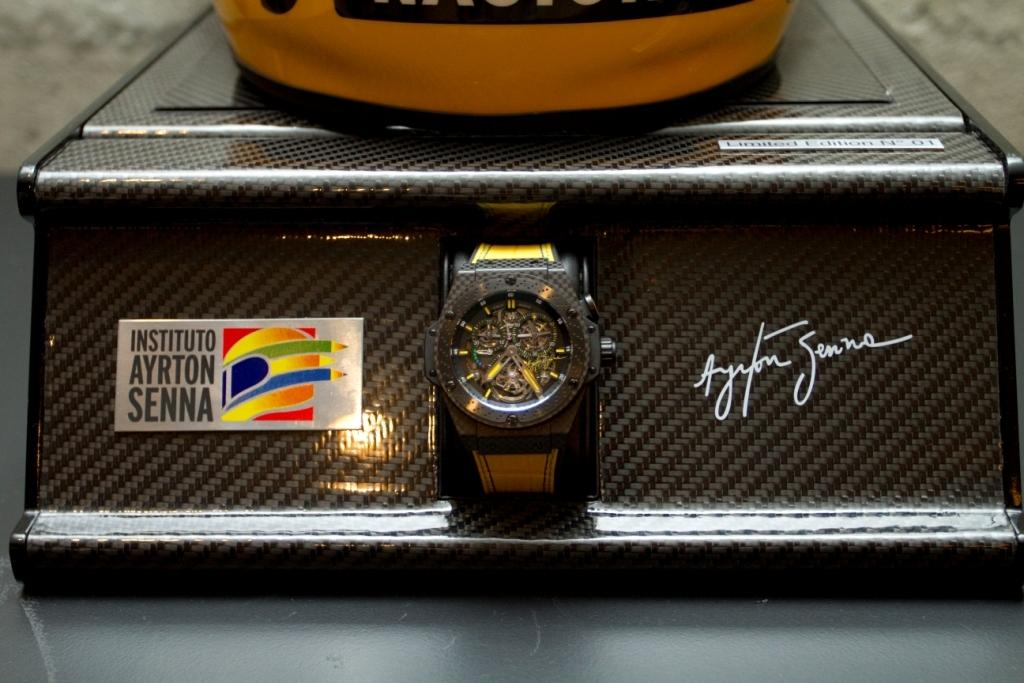<image>
Render a clear and concise summary of the photo. The watch is from the Instituto Ayrton Senna 